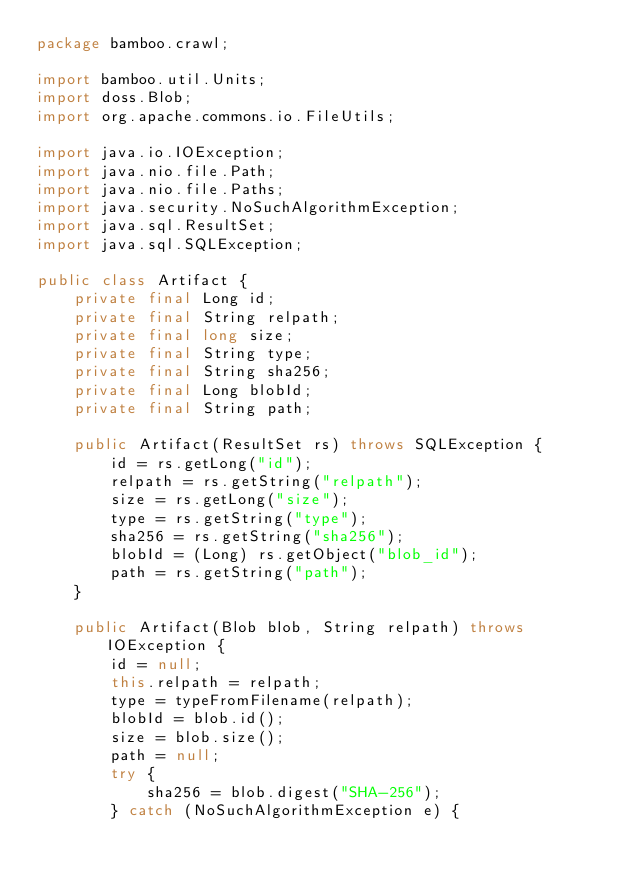<code> <loc_0><loc_0><loc_500><loc_500><_Java_>package bamboo.crawl;

import bamboo.util.Units;
import doss.Blob;
import org.apache.commons.io.FileUtils;

import java.io.IOException;
import java.nio.file.Path;
import java.nio.file.Paths;
import java.security.NoSuchAlgorithmException;
import java.sql.ResultSet;
import java.sql.SQLException;

public class Artifact {
    private final Long id;
    private final String relpath;
    private final long size;
    private final String type;
    private final String sha256;
    private final Long blobId;
    private final String path;

    public Artifact(ResultSet rs) throws SQLException {
        id = rs.getLong("id");
        relpath = rs.getString("relpath");
        size = rs.getLong("size");
        type = rs.getString("type");
        sha256 = rs.getString("sha256");
        blobId = (Long) rs.getObject("blob_id");
        path = rs.getString("path");
    }

    public Artifact(Blob blob, String relpath) throws IOException {
        id = null;
        this.relpath = relpath;
        type = typeFromFilename(relpath);
        blobId = blob.id();
        size = blob.size();
        path = null;
        try {
            sha256 = blob.digest("SHA-256");
        } catch (NoSuchAlgorithmException e) {</code> 